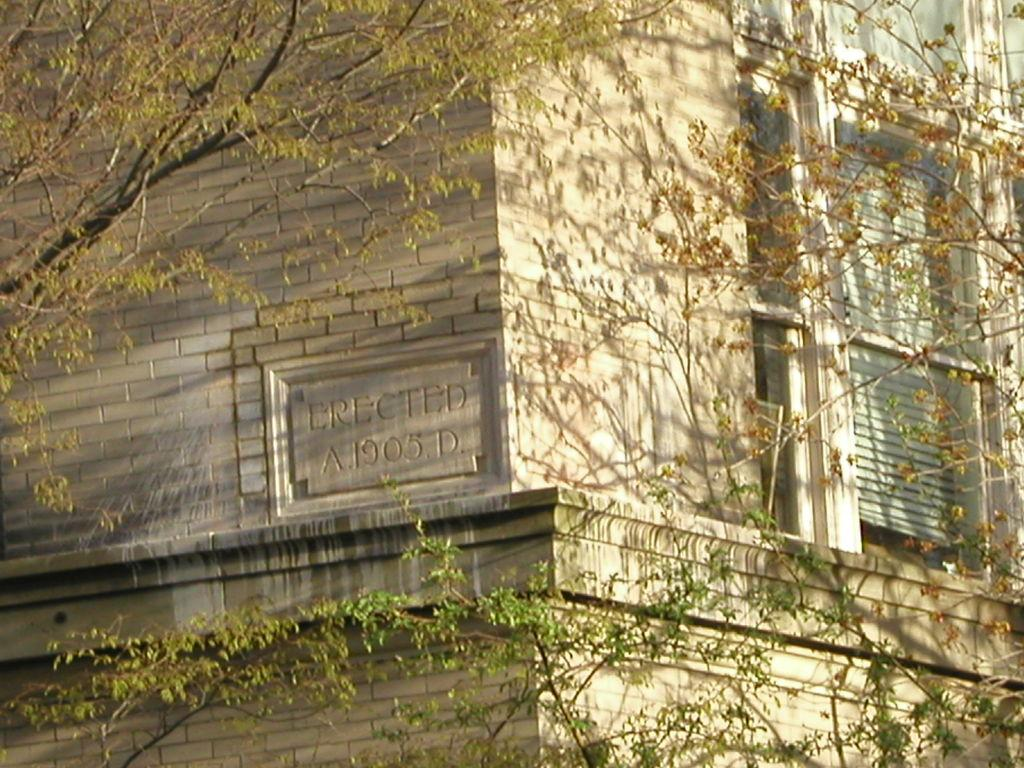What type of structure is present in the image? There is a building in the image. Can you describe any specific features of the building? The building has some text on it. What else can be seen in the image besides the building? There is a window blind and trees visible in the image. How many plantations are visible in the image? There are no plantations present in the image. What type of insect can be seen crawling on the building in the image? There are no insects visible in the image. 